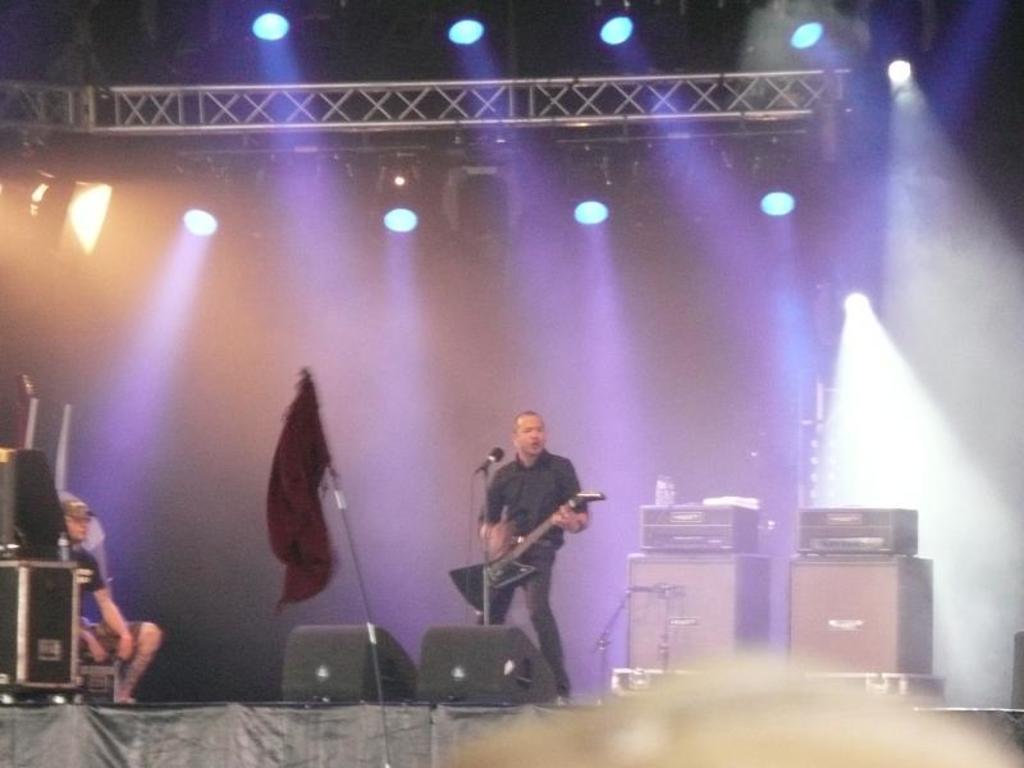Could you give a brief overview of what you see in this image? These are focusing lights. Above this stage a person is playing guitar. Here we can see devices, person, mic and flag. 